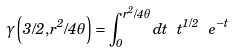Convert formula to latex. <formula><loc_0><loc_0><loc_500><loc_500>\gamma \left ( 3 / 2 , r ^ { 2 } / 4 \theta \right ) = \int _ { 0 } ^ { r ^ { 2 } / 4 \theta } d t \ t ^ { 1 / 2 } \ e ^ { - t }</formula> 